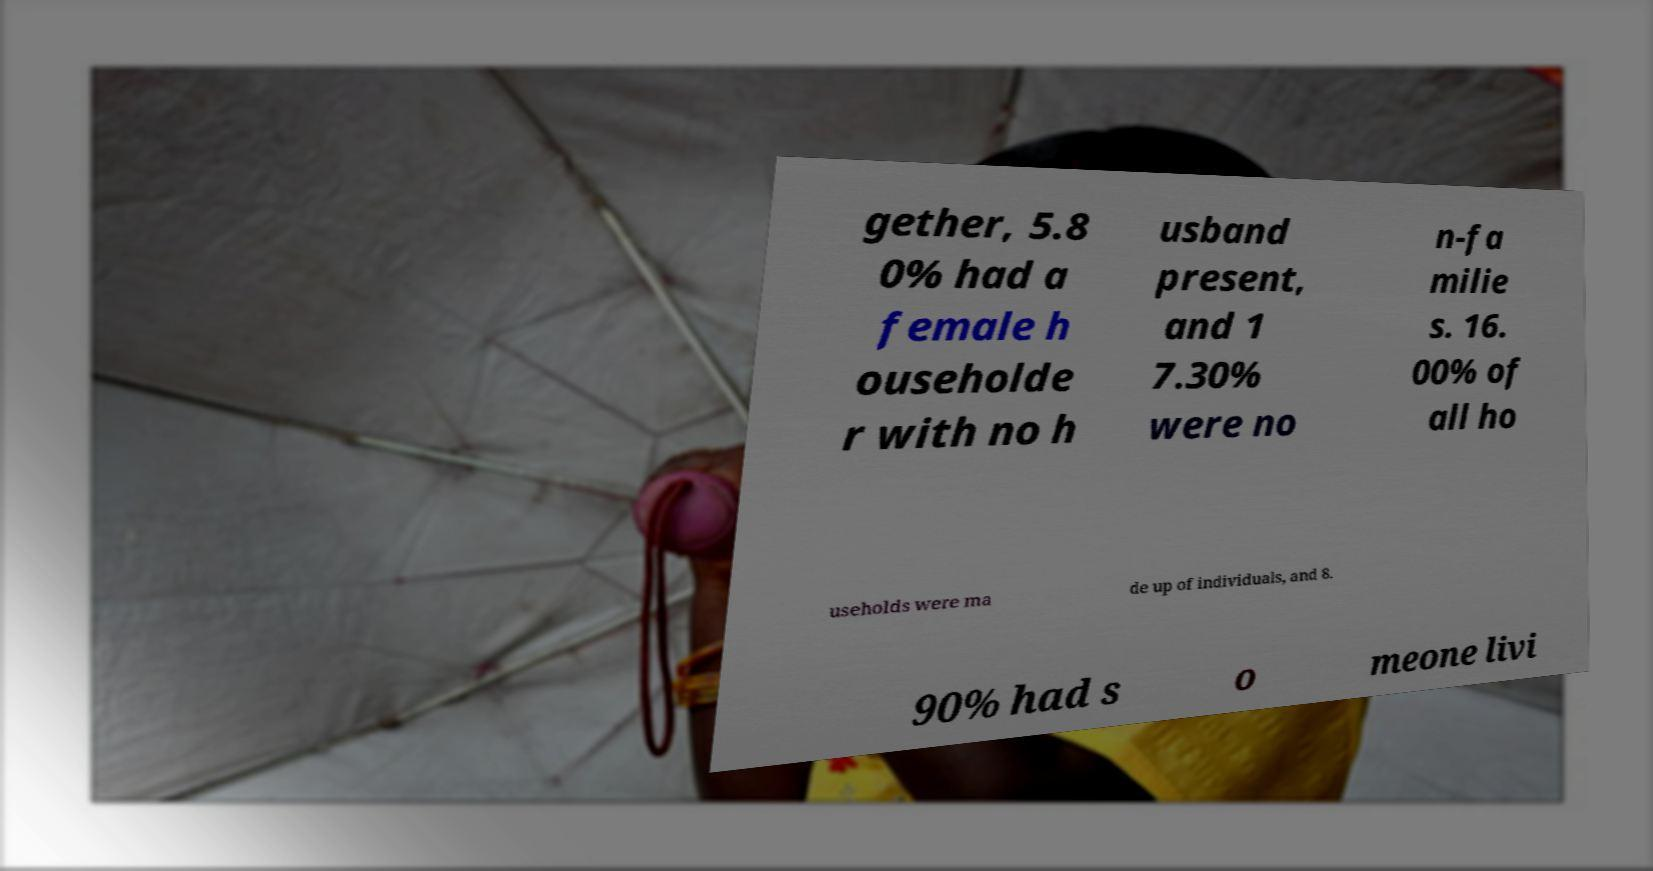What messages or text are displayed in this image? I need them in a readable, typed format. gether, 5.8 0% had a female h ouseholde r with no h usband present, and 1 7.30% were no n-fa milie s. 16. 00% of all ho useholds were ma de up of individuals, and 8. 90% had s o meone livi 